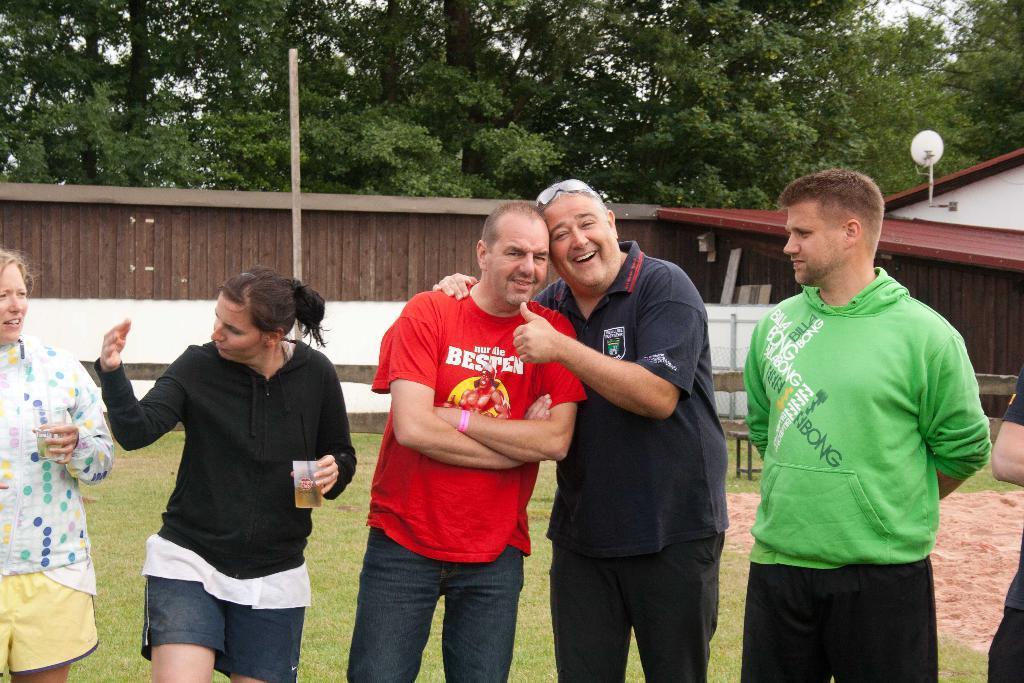Can you describe this image briefly? At the bottom of this image, there are persons in different color dresses. One of them is holding a glass, which is filled with drink. Four of the rest are smiling. In the background, there is a shelter, there are trees, a wooden wall, sand surface, grass on the ground and there is sky. 